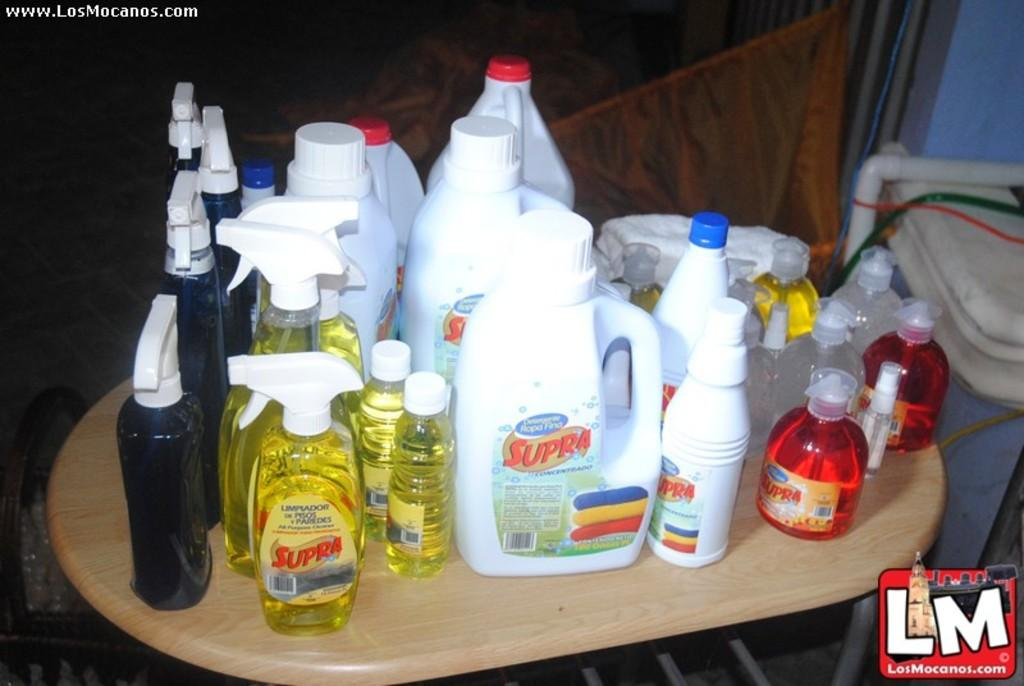<image>
Give a short and clear explanation of the subsequent image. the words LM that are next to some items 